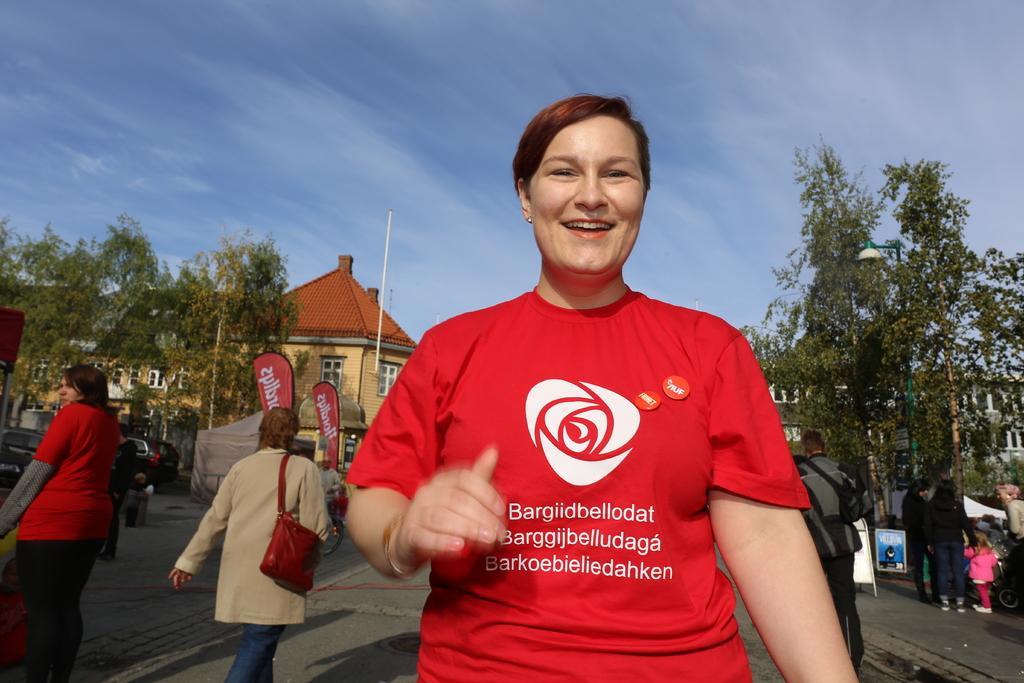How would you summarize this image in a sentence or two? In this image there are people, tents, boards, vehicles, trees, light, buildings, poles banners, cloudy sky and things.   